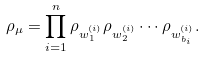Convert formula to latex. <formula><loc_0><loc_0><loc_500><loc_500>\rho _ { \mu } = \prod _ { i = 1 } ^ { n } \rho _ { w ^ { ( i ) } _ { 1 } } \rho _ { w ^ { ( i ) } _ { 2 } } \cdots \rho _ { w ^ { ( i ) } _ { b _ { i } } } .</formula> 